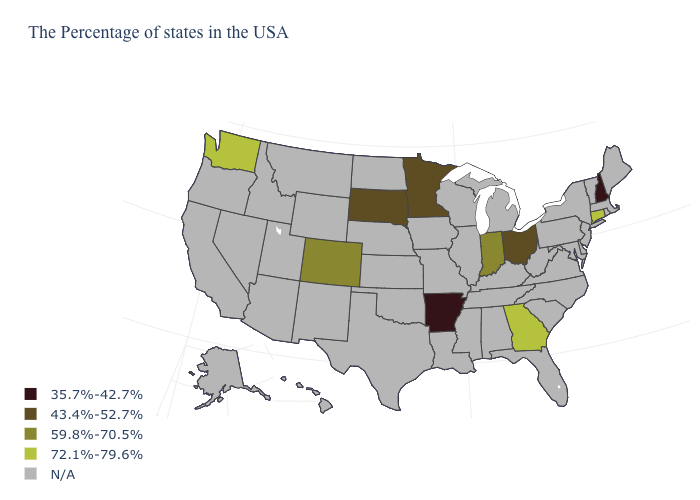How many symbols are there in the legend?
Give a very brief answer. 5. What is the value of Utah?
Keep it brief. N/A. Name the states that have a value in the range N/A?
Quick response, please. Maine, Massachusetts, Rhode Island, Vermont, New York, New Jersey, Delaware, Maryland, Pennsylvania, Virginia, North Carolina, South Carolina, West Virginia, Florida, Michigan, Kentucky, Alabama, Tennessee, Wisconsin, Illinois, Mississippi, Louisiana, Missouri, Iowa, Kansas, Nebraska, Oklahoma, Texas, North Dakota, Wyoming, New Mexico, Utah, Montana, Arizona, Idaho, Nevada, California, Oregon, Alaska, Hawaii. What is the value of Tennessee?
Be succinct. N/A. Name the states that have a value in the range 35.7%-42.7%?
Concise answer only. New Hampshire, Arkansas. Name the states that have a value in the range 43.4%-52.7%?
Write a very short answer. Ohio, Minnesota, South Dakota. Does the map have missing data?
Be succinct. Yes. Name the states that have a value in the range 72.1%-79.6%?
Answer briefly. Connecticut, Georgia, Washington. What is the value of Illinois?
Keep it brief. N/A. Which states have the lowest value in the USA?
Answer briefly. New Hampshire, Arkansas. Does Indiana have the highest value in the MidWest?
Answer briefly. Yes. Name the states that have a value in the range 43.4%-52.7%?
Short answer required. Ohio, Minnesota, South Dakota. Which states hav the highest value in the West?
Keep it brief. Washington. 